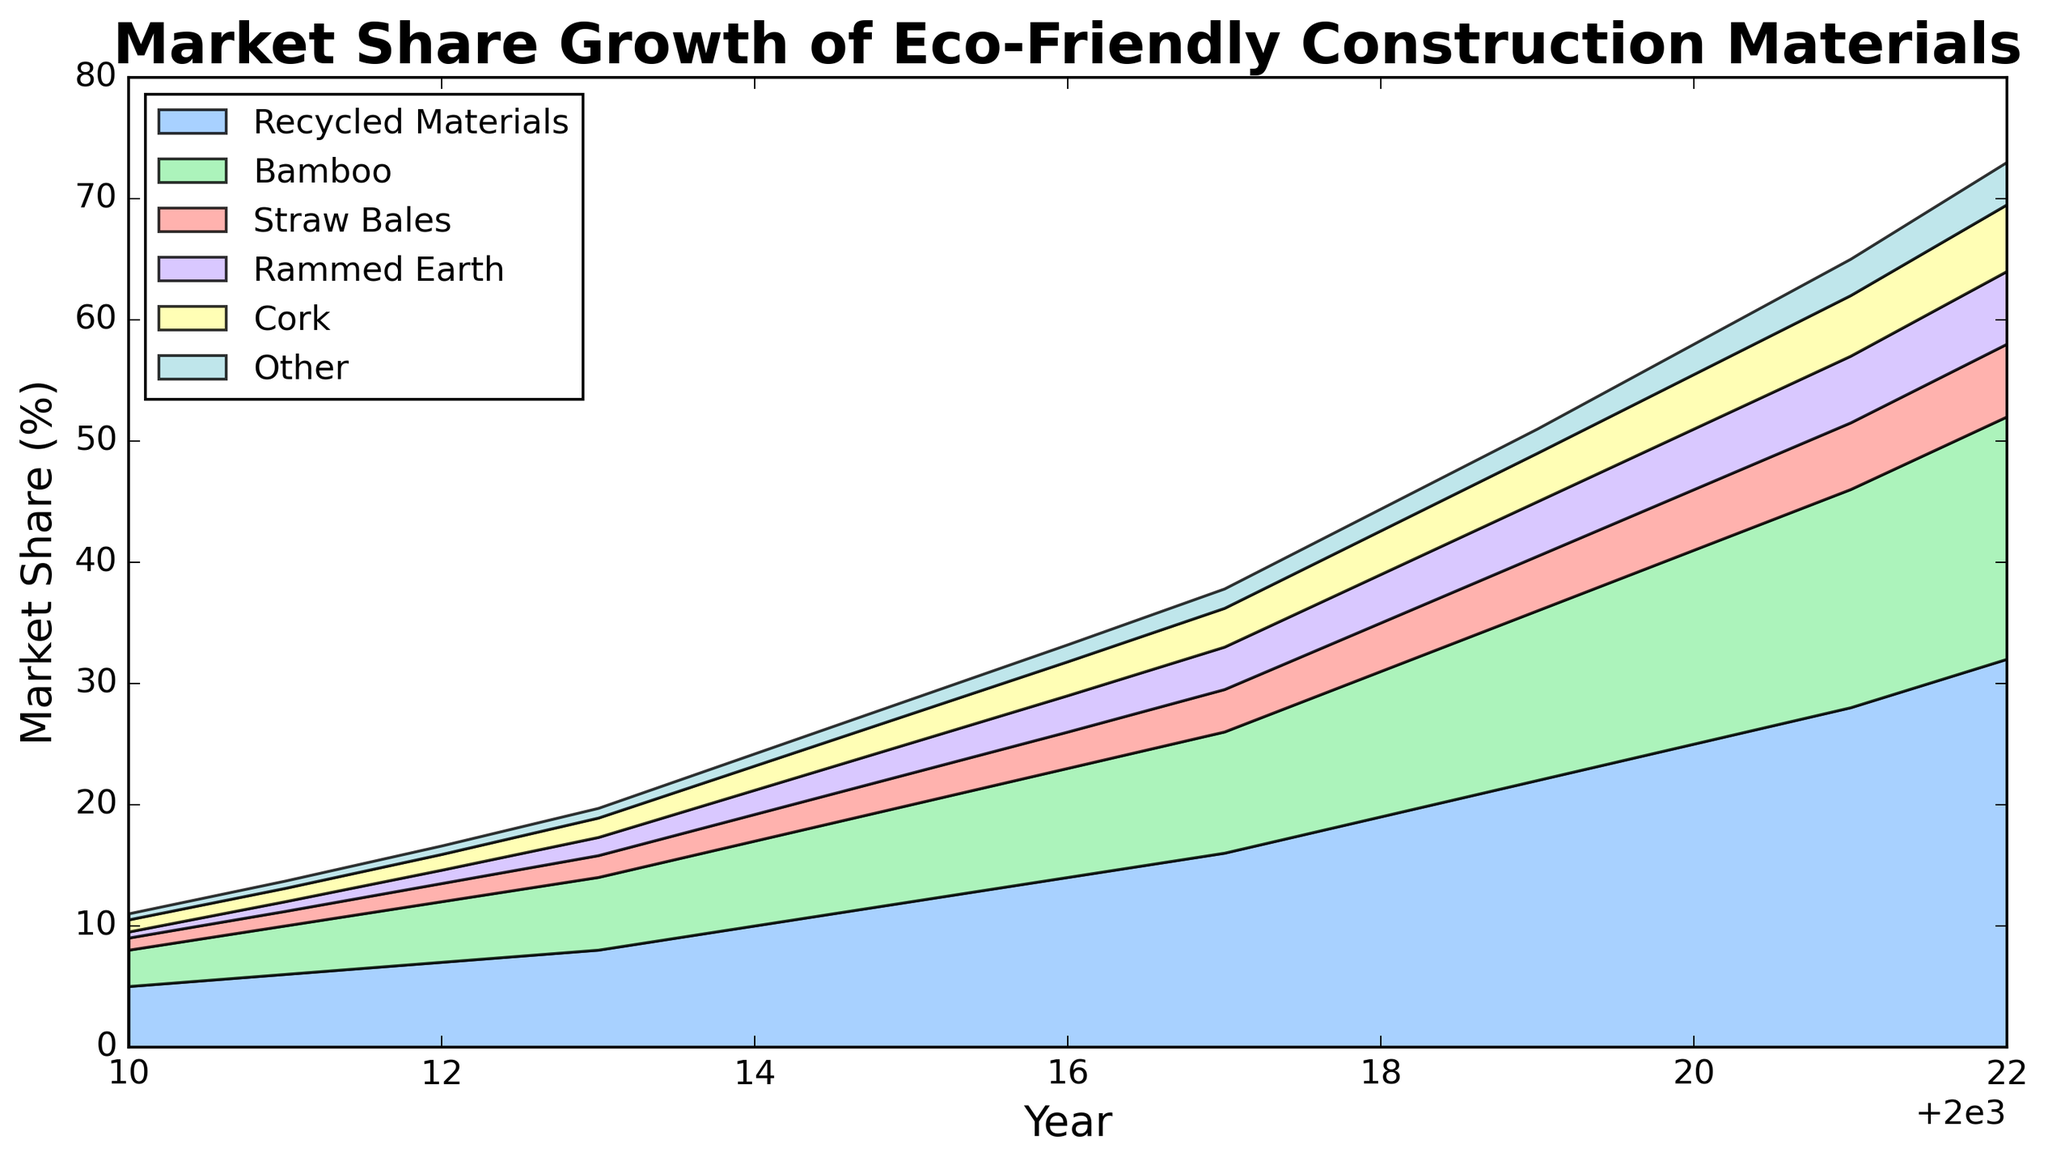What was the market share of Recycled Materials in 2015? Locate the year 2015 on the x-axis and then find the corresponding value for Recycled Materials on the chart.
Answer: 12% Which material had the highest market share in 2022? Observe the height of the areas stacked on top of each other for the year 2022, and identify which material's area is the largest.
Answer: Recycled Materials Between 2015 and 2020, which material showed the most significant growth in market share? Compare the values of all materials in 2015 and 2020, and calculate the difference for each. The material with the largest increase indicates the most significant growth.
Answer: Recycled Materials Compare the market share of Bamboo and Straw Bales in 2018. Which one was higher, and by how much? Locate the year 2018 on the x-axis, and find the values for Bamboo and Straw Bales. Subtract the Straw Bales value from the Bamboo value to find the difference.
Answer: Bamboo by 8% What is the combined market share of Cork and Rammed Earth in the year 2017? Identify the market share values of Cork and Rammed Earth for the year 2017 and sum them up.
Answer: 6.7% Which material had its market share consistently increasing from 2010 to 2022? Examine the trend lines for each material from 2010 to 2022 and check if they are consistently going upwards.
Answer: Recycled Materials (also Bamboo) How much did the market share of Rammed Earth increase from 2010 to 2022? Identify the market share of Rammed Earth in 2010 and 2022, and calculate the difference between these two values.
Answer: 5.5% Is there any year when Other materials took up exactly twice the market share of Straw Bales? For each year, find the market share for Other materials and Straw Bales, check if the value for Other materials is exactly twice the value of Straw Bales.
Answer: No In which year was the total market share of all materials exactly 30%? Sum the market share values of all materials for each year and determine if they equal 30%.
Answer: No year had exactly 30% total share How does the growth rate of Cork compare between the periods 2013-2017 and 2017-2022? Calculate the growth rate for Cork from 2013 to 2017 and from 2017 to 2022 by using the values at the start and end of each period. Compare these growth rates.
Answer: Faster from 2017-2022 